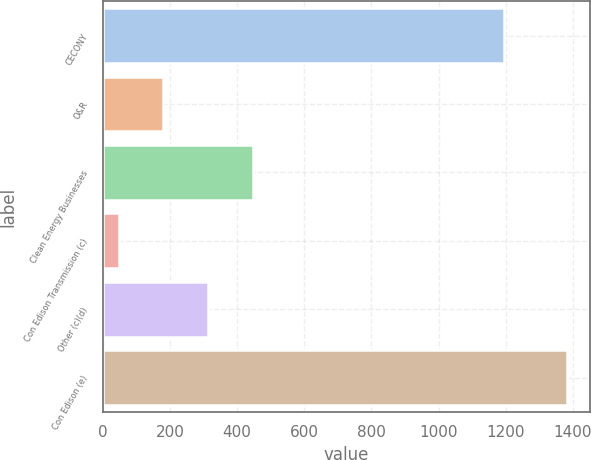Convert chart to OTSL. <chart><loc_0><loc_0><loc_500><loc_500><bar_chart><fcel>CECONY<fcel>O&R<fcel>Clean Energy Businesses<fcel>Con Edison Transmission (c)<fcel>Other (c)(d)<fcel>Con Edison (e)<nl><fcel>1196<fcel>180.5<fcel>447.5<fcel>47<fcel>314<fcel>1382<nl></chart> 